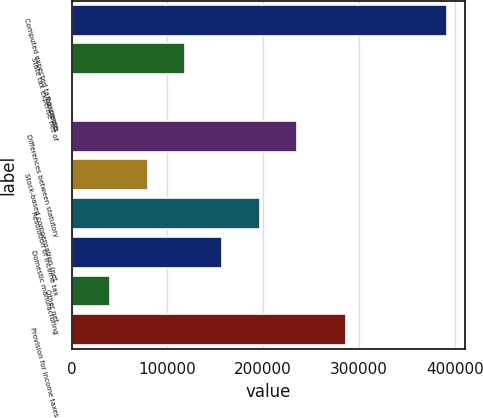Convert chart. <chart><loc_0><loc_0><loc_500><loc_500><bar_chart><fcel>Computed expected tax expense<fcel>State tax expense net of<fcel>Tax credits<fcel>Differences between statutory<fcel>Stock-based compensation (net<fcel>Resolution of income tax<fcel>Domestic manufacturing<fcel>Other net<fcel>Provision for income taxes<nl><fcel>391578<fcel>118332<fcel>1226<fcel>235437<fcel>79296.4<fcel>196402<fcel>157367<fcel>40261.2<fcel>286019<nl></chart> 